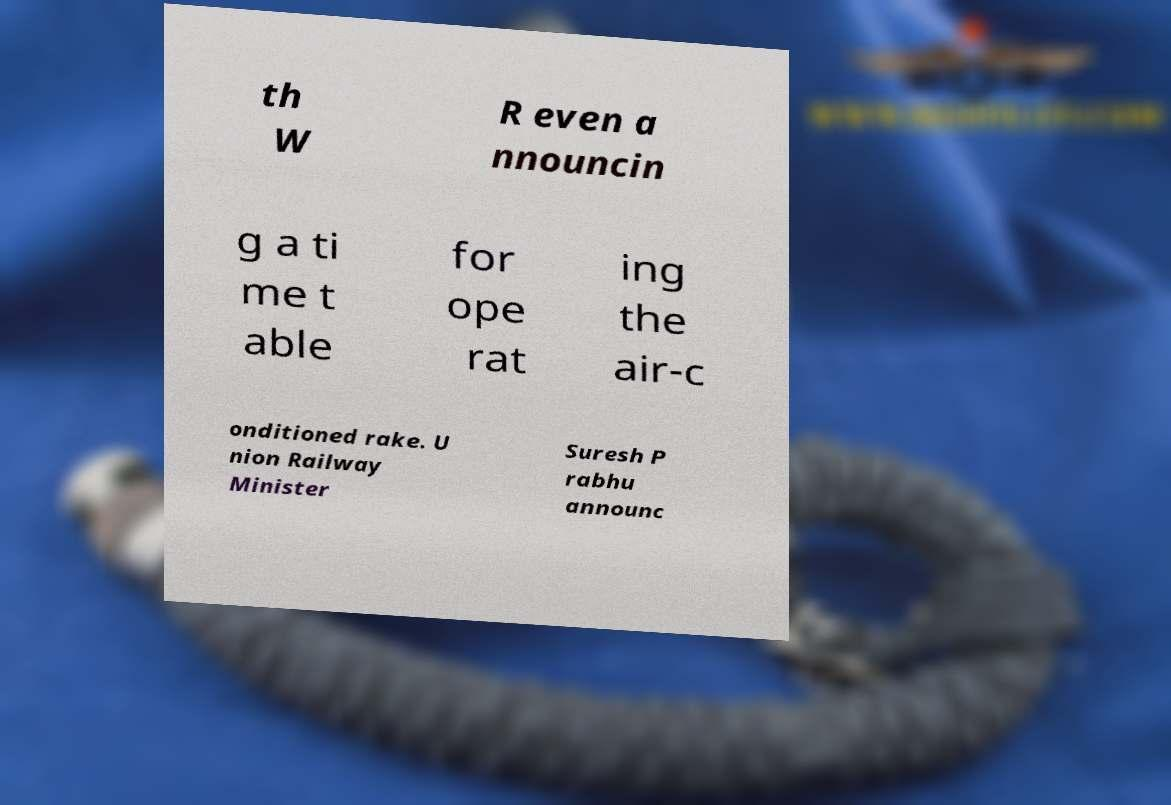For documentation purposes, I need the text within this image transcribed. Could you provide that? th W R even a nnouncin g a ti me t able for ope rat ing the air-c onditioned rake. U nion Railway Minister Suresh P rabhu announc 